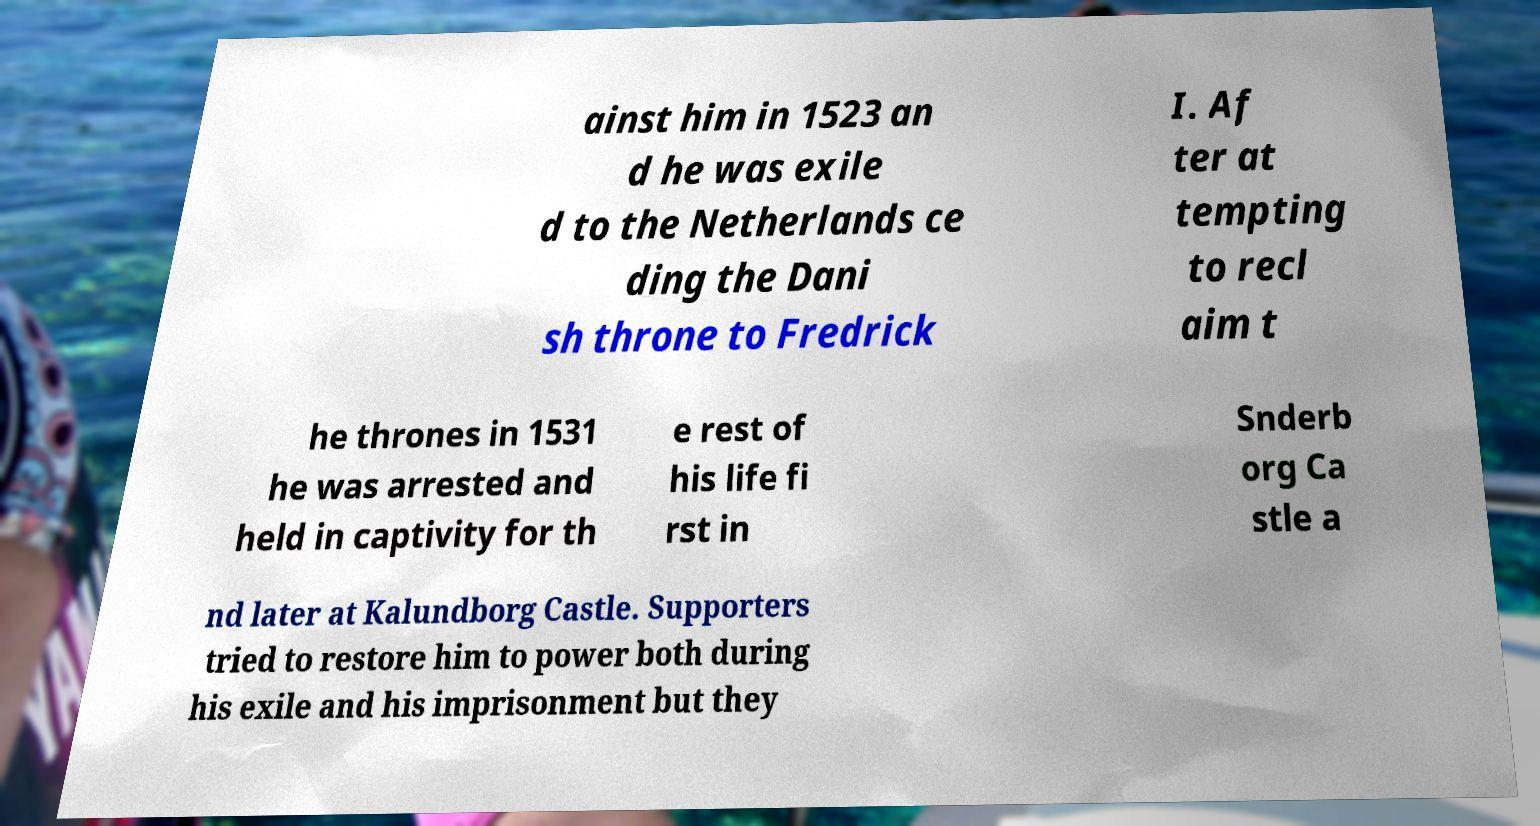For documentation purposes, I need the text within this image transcribed. Could you provide that? ainst him in 1523 an d he was exile d to the Netherlands ce ding the Dani sh throne to Fredrick I. Af ter at tempting to recl aim t he thrones in 1531 he was arrested and held in captivity for th e rest of his life fi rst in Snderb org Ca stle a nd later at Kalundborg Castle. Supporters tried to restore him to power both during his exile and his imprisonment but they 